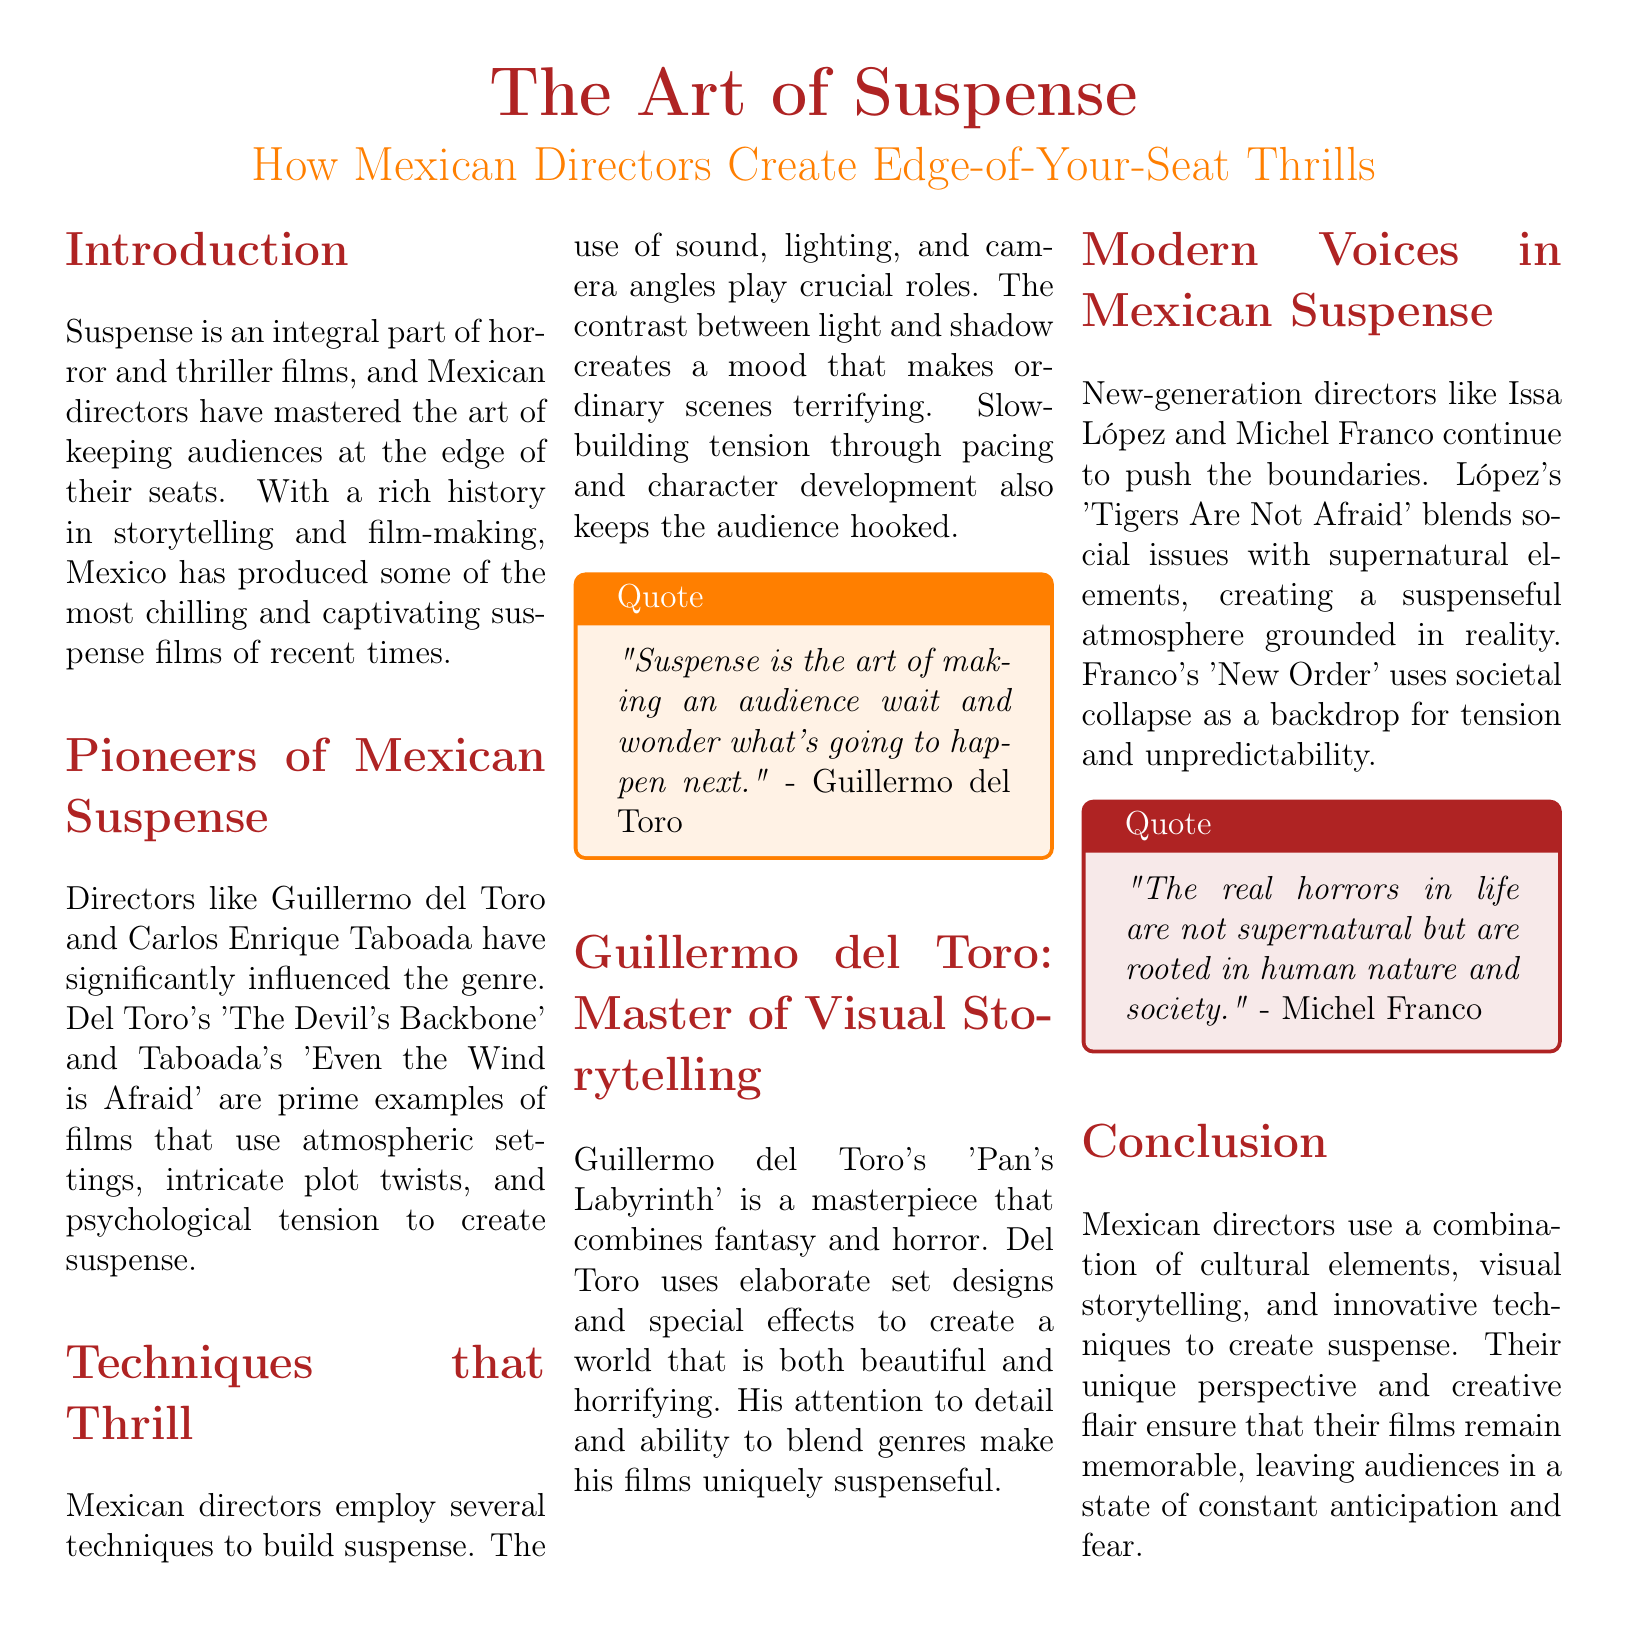what is the title of the document? The title of the document is prominently displayed at the beginning and is "The Art of Suspense."
Answer: The Art of Suspense who is a pioneer of Mexican suspense? The document mentions Guillermo del Toro and Carlos Enrique Taboada as pioneers.
Answer: Guillermo del Toro what film is associated with Guillermo del Toro? The document lists "The Devil's Backbone" as a significant work of Guillermo del Toro.
Answer: The Devil's Backbone which technique is crucial for building suspense according to the document? The document highlights the use of sound, lighting, and camera angles as crucial techniques.
Answer: Sound, lighting, and camera angles which director created "Tigers Are Not Afraid"? The document states that Issa López is the director of "Tigers Are Not Afraid."
Answer: Issa López what is the primary theme in Michel Franco's "New Order"? The document indicates that "New Order" uses societal collapse as a theme.
Answer: Societal collapse who said, "Suspense is the art of making an audience wait and wonder what's going to happen next"? The document attributes this quote to Guillermo del Toro.
Answer: Guillermo del Toro how do Mexican directors keep audiences at the edge of their seats? The document explains that they use a combination of cultural elements, visual storytelling, and innovative techniques.
Answer: Cultural elements, visual storytelling, and innovative techniques what genre does Guillermo del Toro's "Pan's Labyrinth" combine? The document states that "Pan's Labyrinth" combines fantasy and horror.
Answer: Fantasy and horror 